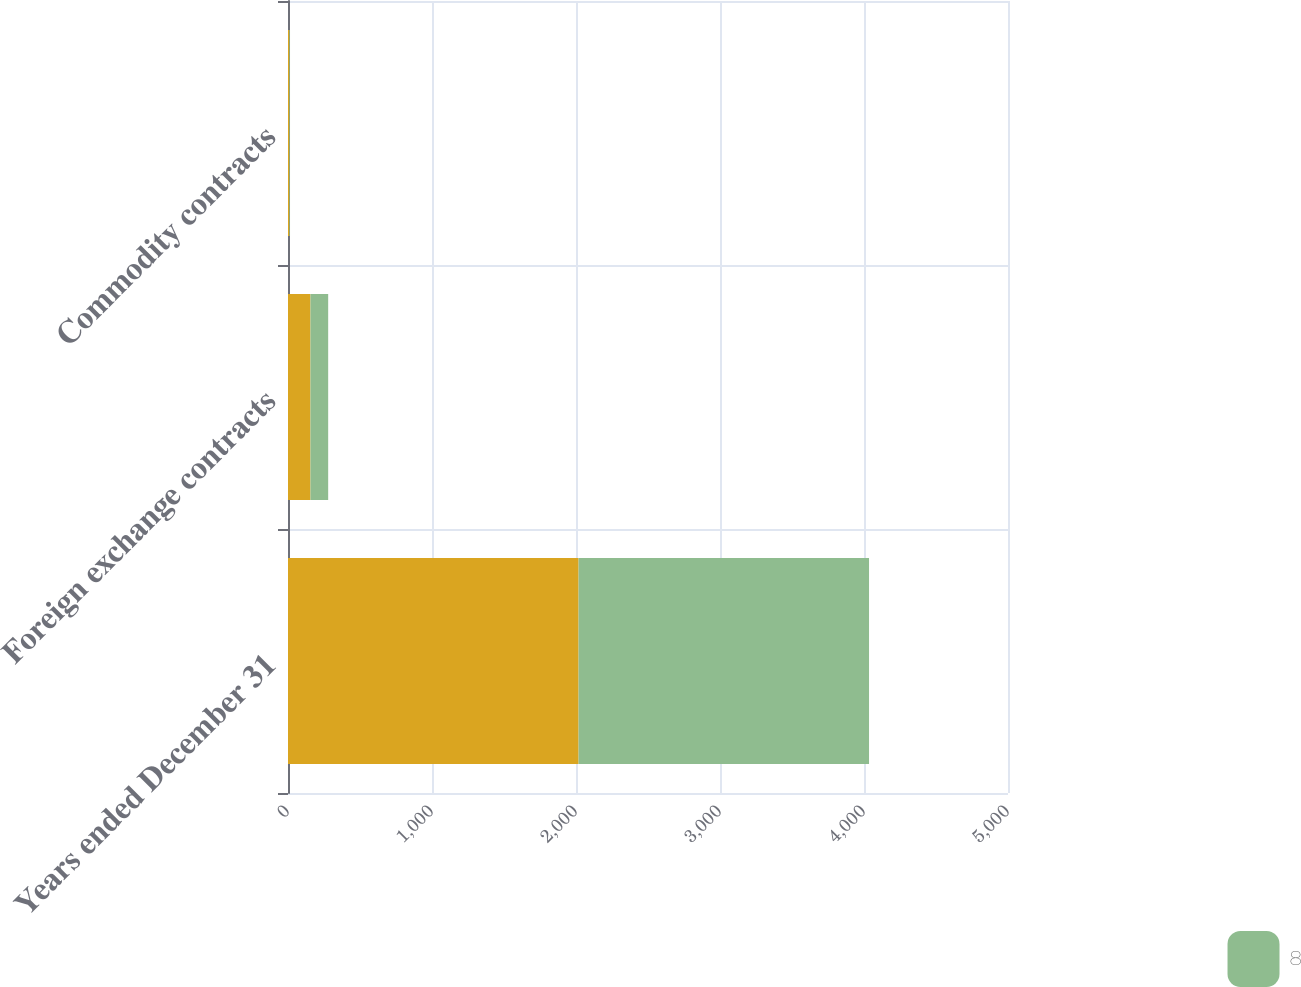Convert chart. <chart><loc_0><loc_0><loc_500><loc_500><stacked_bar_chart><ecel><fcel>Years ended December 31<fcel>Foreign exchange contracts<fcel>Commodity contracts<nl><fcel>nan<fcel>2018<fcel>156<fcel>10<nl><fcel>8<fcel>2017<fcel>123<fcel>4<nl></chart> 